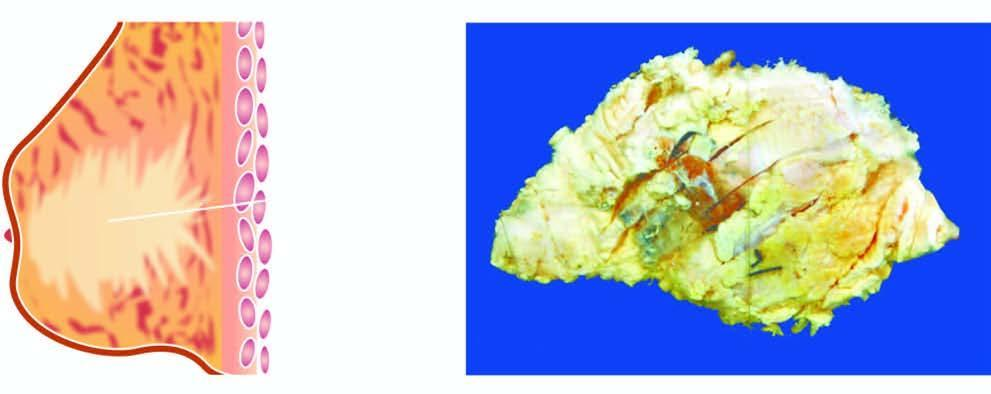does 2,3-bpg and co2 show a tumour extending up to nipple and areola?
Answer the question using a single word or phrase. No 